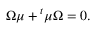Convert formula to latex. <formula><loc_0><loc_0><loc_500><loc_500>\Omega \mu ^ { t } \mu \Omega = 0 .</formula> 